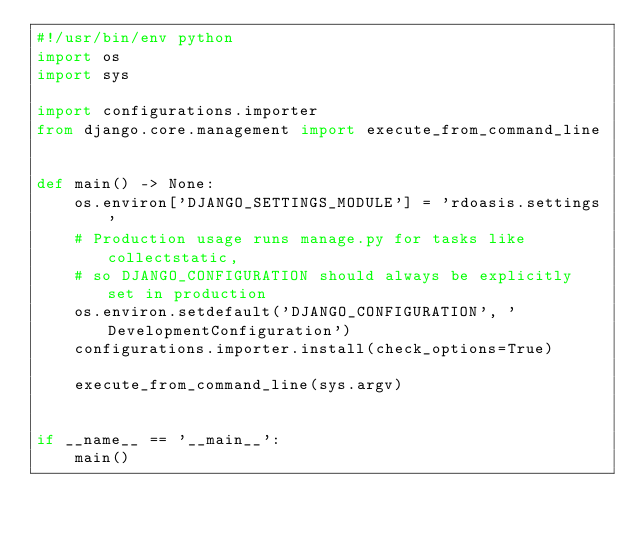Convert code to text. <code><loc_0><loc_0><loc_500><loc_500><_Python_>#!/usr/bin/env python
import os
import sys

import configurations.importer
from django.core.management import execute_from_command_line


def main() -> None:
    os.environ['DJANGO_SETTINGS_MODULE'] = 'rdoasis.settings'
    # Production usage runs manage.py for tasks like collectstatic,
    # so DJANGO_CONFIGURATION should always be explicitly set in production
    os.environ.setdefault('DJANGO_CONFIGURATION', 'DevelopmentConfiguration')
    configurations.importer.install(check_options=True)

    execute_from_command_line(sys.argv)


if __name__ == '__main__':
    main()
</code> 